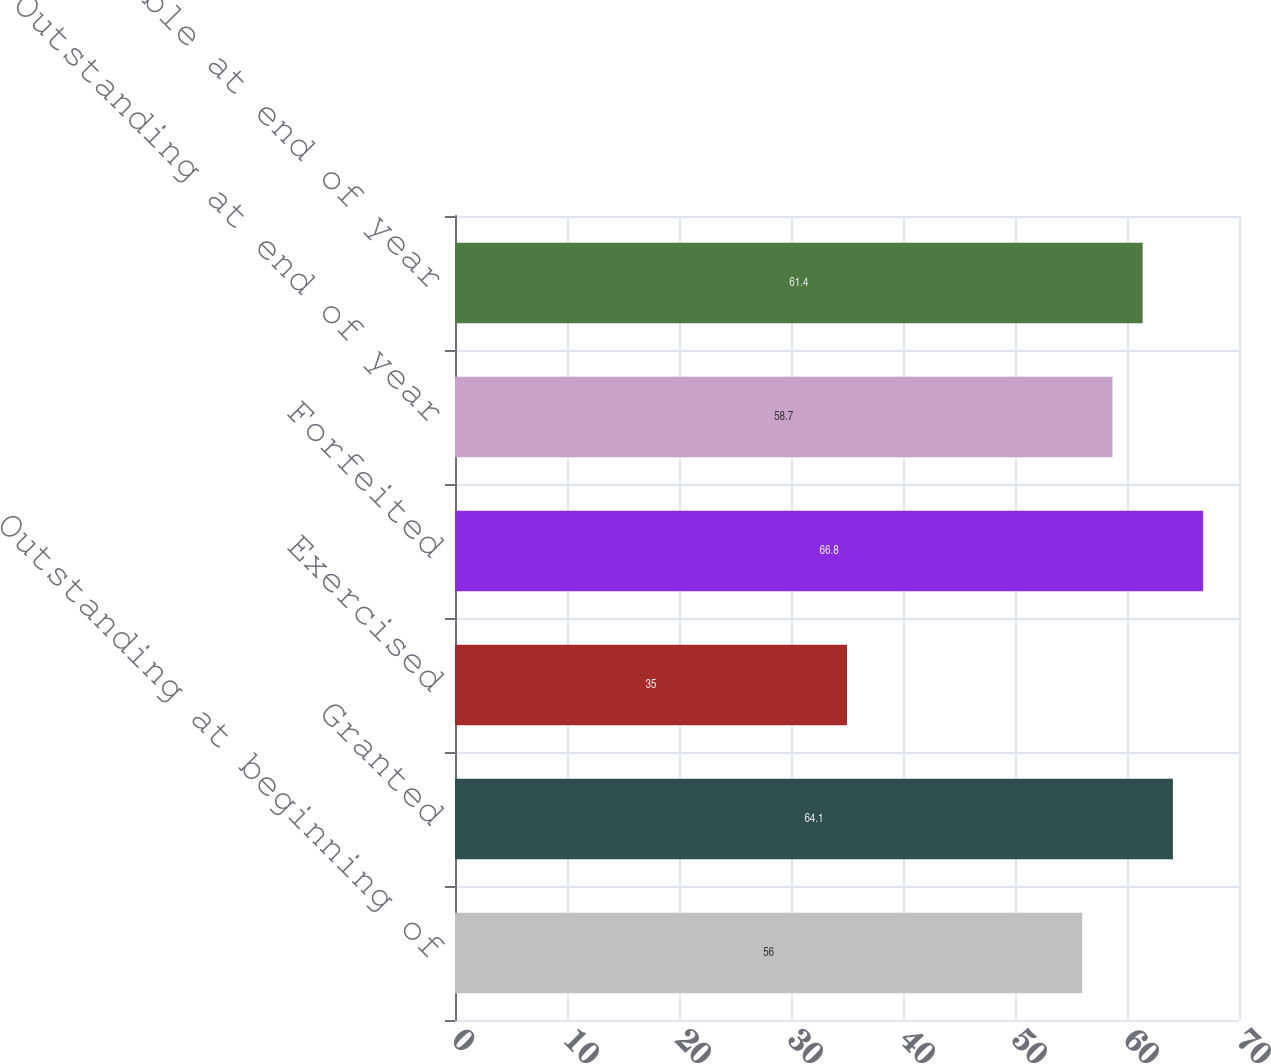Convert chart. <chart><loc_0><loc_0><loc_500><loc_500><bar_chart><fcel>Outstanding at beginning of<fcel>Granted<fcel>Exercised<fcel>Forfeited<fcel>Outstanding at end of year<fcel>Exercisable at end of year<nl><fcel>56<fcel>64.1<fcel>35<fcel>66.8<fcel>58.7<fcel>61.4<nl></chart> 